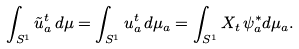Convert formula to latex. <formula><loc_0><loc_0><loc_500><loc_500>\int _ { S ^ { 1 } } \tilde { u } _ { a } ^ { t } \, d \mu = \int _ { S ^ { 1 } } u _ { a } ^ { t } \, d \mu _ { a } = \int _ { S ^ { 1 } } X _ { t } \, \psi _ { a } ^ { * } d \mu _ { a } .</formula> 